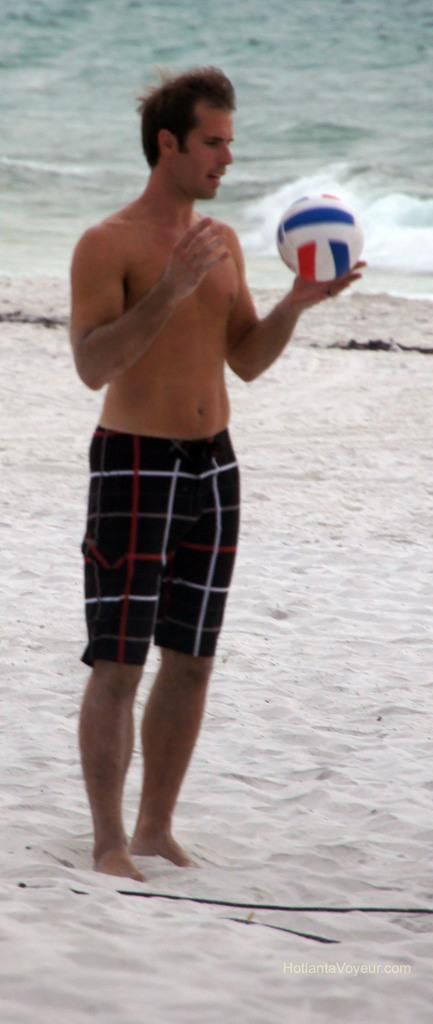Who is present in the image? There is a man in the image. Where is the man located? The man is standing on a beach. What is the man holding in his hand? The man is holding a ball in his hand. What can be seen in the background of the image? Water is visible in the image. What type of scent can be detected from the man in the image? There is no information about the man's scent in the image, so it cannot be determined. 